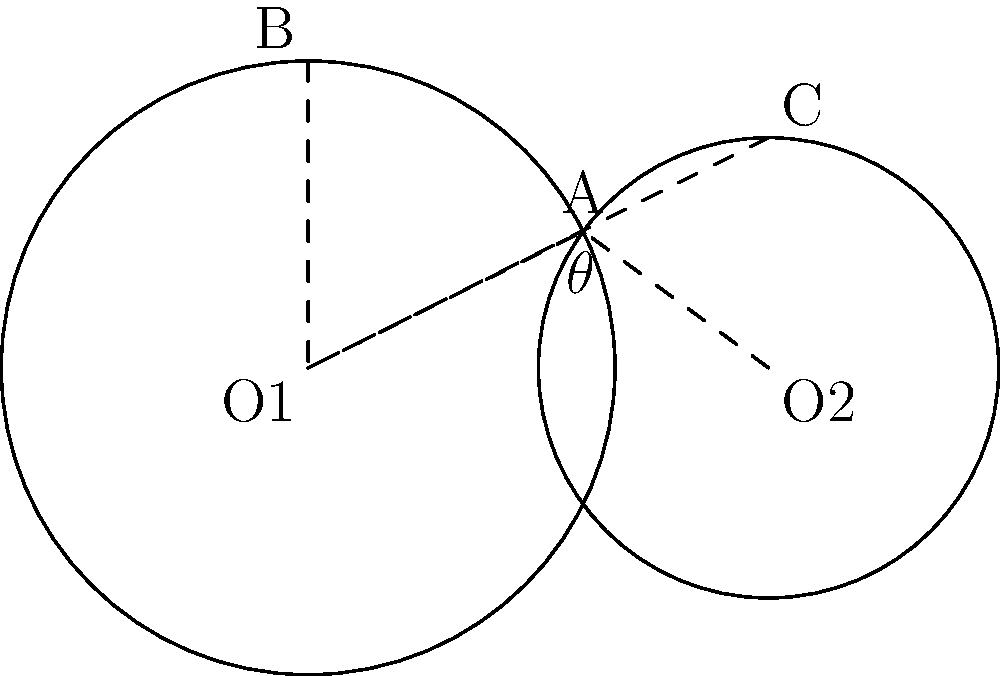You have two mixing bowls of different sizes touching each other. The larger bowl has a radius of 8 inches, and the smaller bowl has a radius of 6 inches. What is the angle $\theta$ formed at the point where the bowls touch? Let's approach this step-by-step:

1) In circle geometry, when two circles touch externally, they form a triangle with the centers of the circles and the point of contact.

2) In this case, we have:
   - Radius of larger bowl (R) = 8 inches
   - Radius of smaller bowl (r) = 6 inches
   - Distance between centers (d) = R + r = 8 + 6 = 14 inches

3) We now have a triangle with sides 8, 6, and 14.

4) We can use the cosine law to find the angle $\theta$:

   $$\cos \theta = \frac{R^2 + d^2 - r^2}{2Rd}$$

5) Substituting our values:

   $$\cos \theta = \frac{8^2 + 14^2 - 6^2}{2 * 8 * 14}$$

6) Simplifying:

   $$\cos \theta = \frac{64 + 196 - 36}{224} = \frac{224}{224} = 1$$

7) If $\cos \theta = 1$, then $\theta = 0°$

Therefore, the angle formed at the point where the bowls touch is 0°.
Answer: 0° 